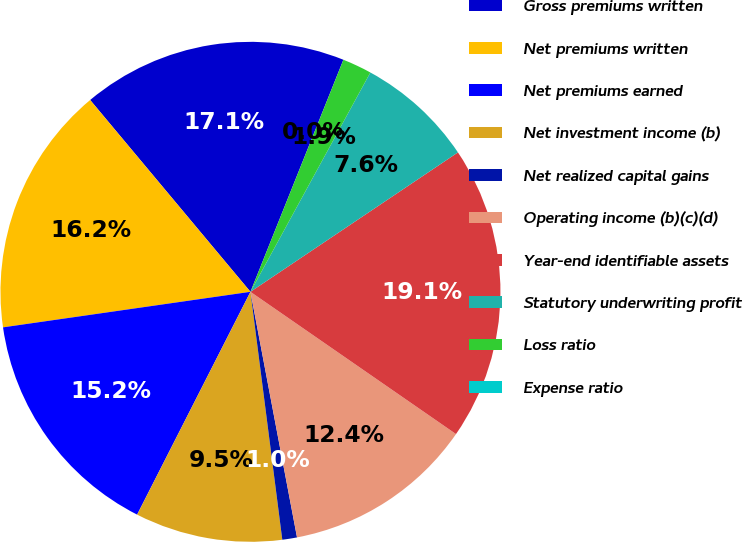Convert chart to OTSL. <chart><loc_0><loc_0><loc_500><loc_500><pie_chart><fcel>Gross premiums written<fcel>Net premiums written<fcel>Net premiums earned<fcel>Net investment income (b)<fcel>Net realized capital gains<fcel>Operating income (b)(c)(d)<fcel>Year-end identifiable assets<fcel>Statutory underwriting profit<fcel>Loss ratio<fcel>Expense ratio<nl><fcel>17.14%<fcel>16.19%<fcel>15.24%<fcel>9.52%<fcel>0.95%<fcel>12.38%<fcel>19.05%<fcel>7.62%<fcel>1.9%<fcel>0.0%<nl></chart> 